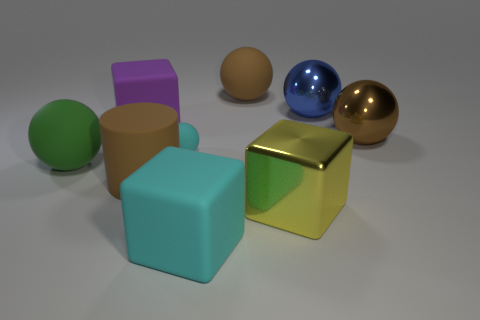Subtract all matte spheres. How many spheres are left? 2 Subtract all gray cubes. How many brown balls are left? 2 Subtract all cyan blocks. How many blocks are left? 2 Subtract 0 blue cylinders. How many objects are left? 9 Subtract all cubes. How many objects are left? 6 Subtract 1 cubes. How many cubes are left? 2 Subtract all cyan cylinders. Subtract all brown blocks. How many cylinders are left? 1 Subtract all large brown cylinders. Subtract all big yellow spheres. How many objects are left? 8 Add 7 big blue metallic things. How many big blue metallic things are left? 8 Add 1 large purple balls. How many large purple balls exist? 1 